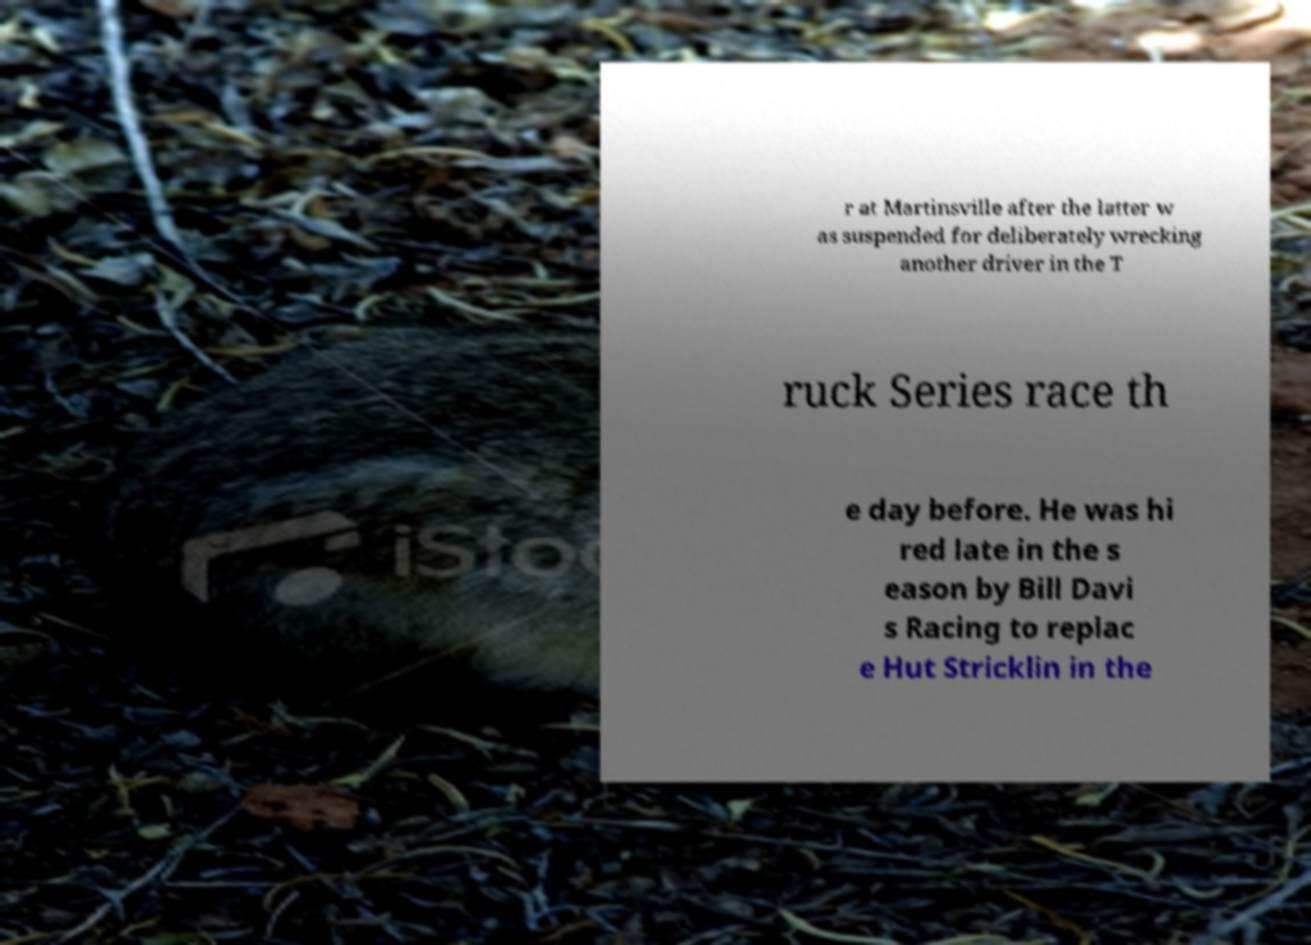What messages or text are displayed in this image? I need them in a readable, typed format. r at Martinsville after the latter w as suspended for deliberately wrecking another driver in the T ruck Series race th e day before. He was hi red late in the s eason by Bill Davi s Racing to replac e Hut Stricklin in the 